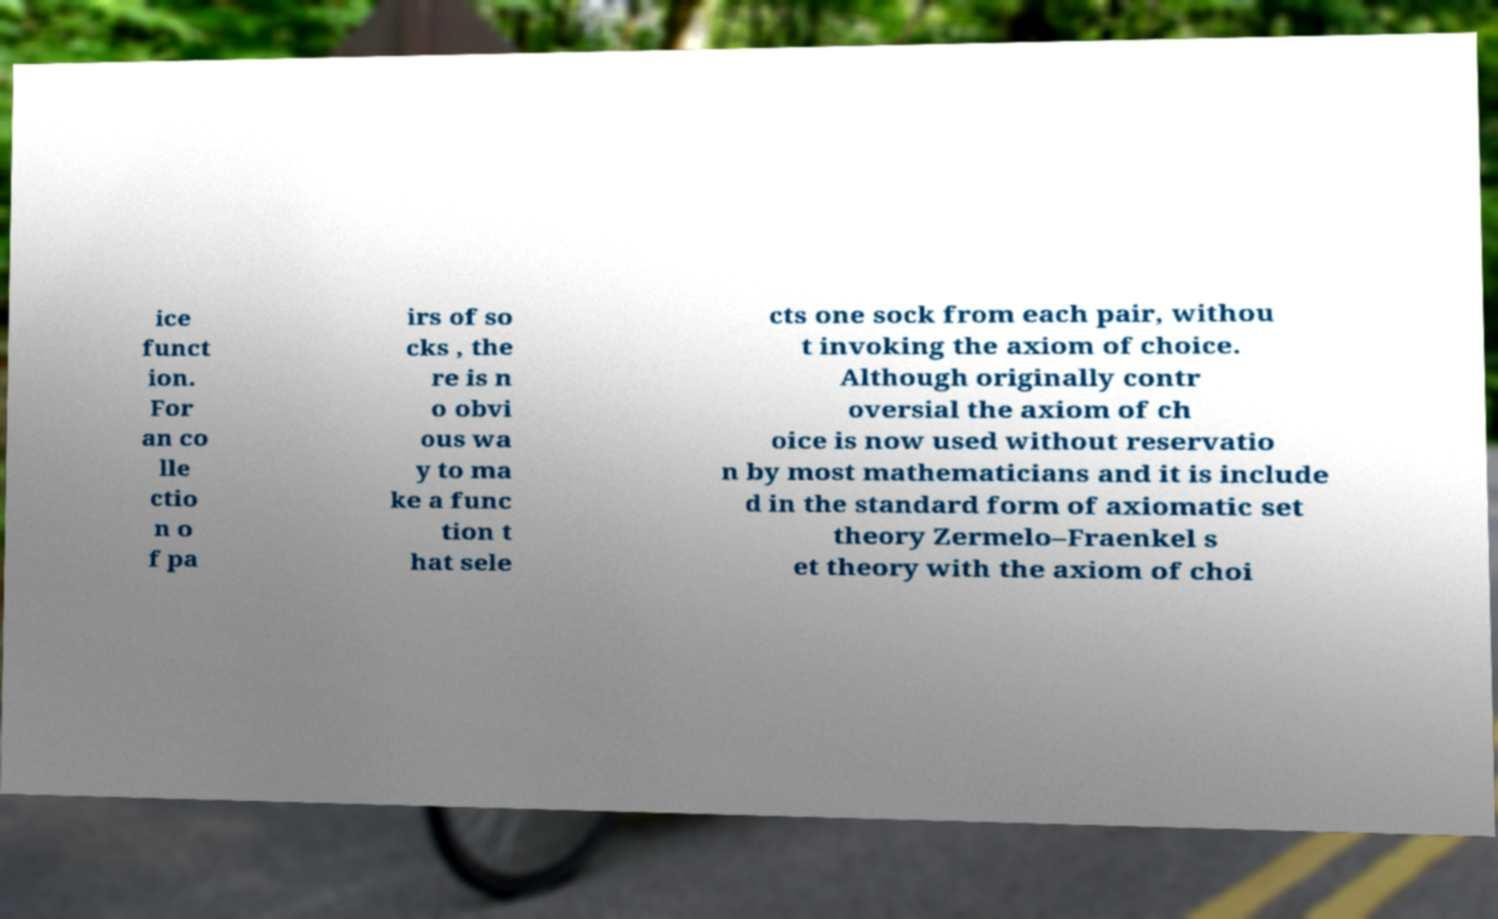Can you read and provide the text displayed in the image?This photo seems to have some interesting text. Can you extract and type it out for me? ice funct ion. For an co lle ctio n o f pa irs of so cks , the re is n o obvi ous wa y to ma ke a func tion t hat sele cts one sock from each pair, withou t invoking the axiom of choice. Although originally contr oversial the axiom of ch oice is now used without reservatio n by most mathematicians and it is include d in the standard form of axiomatic set theory Zermelo–Fraenkel s et theory with the axiom of choi 